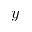<formula> <loc_0><loc_0><loc_500><loc_500>y</formula> 